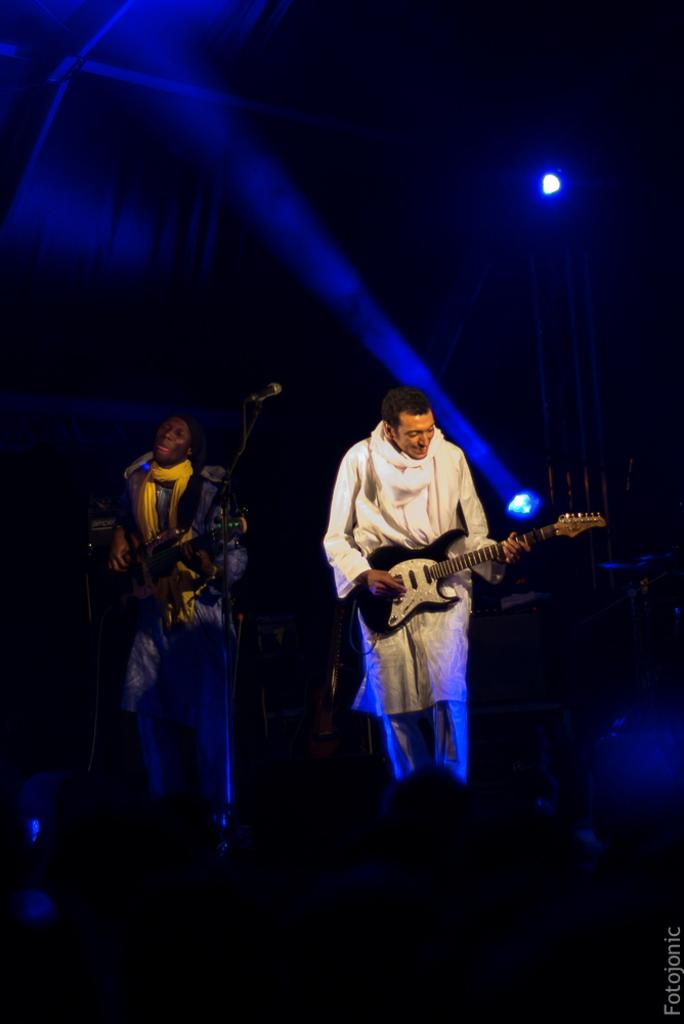How many musicians are in the image? There are two musicians in the image. What instruments are the musicians playing? The musicians are playing guitars. What is present between the musicians? There is a microphone between the musicians. What can be seen behind the musicians? There are spotlights behind the musicians. How would you describe the lighting in the image? The background of the image is dark. What is the musicians' tendency to play the guitar in the image? There is no indication of a tendency in the image; the musicians are simply playing their guitars. Can you tell me how many hydrants are visible in the image? There are no hydrants present in the image. 